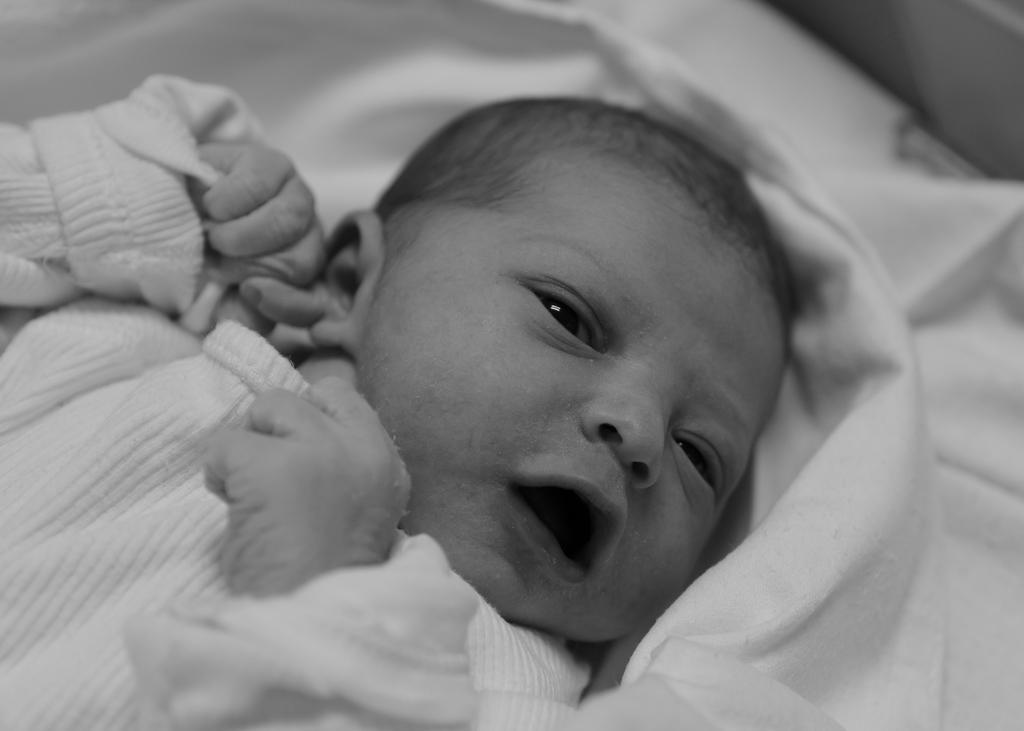How would you summarize this image in a sentence or two? In the image we can see a picture of a baby wearing clothes and the white cloth. 